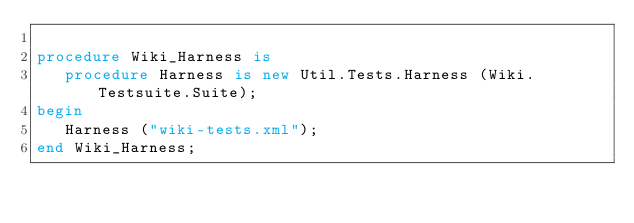Convert code to text. <code><loc_0><loc_0><loc_500><loc_500><_Ada_>
procedure Wiki_Harness is
   procedure Harness is new Util.Tests.Harness (Wiki.Testsuite.Suite);
begin
   Harness ("wiki-tests.xml");
end Wiki_Harness;
</code> 